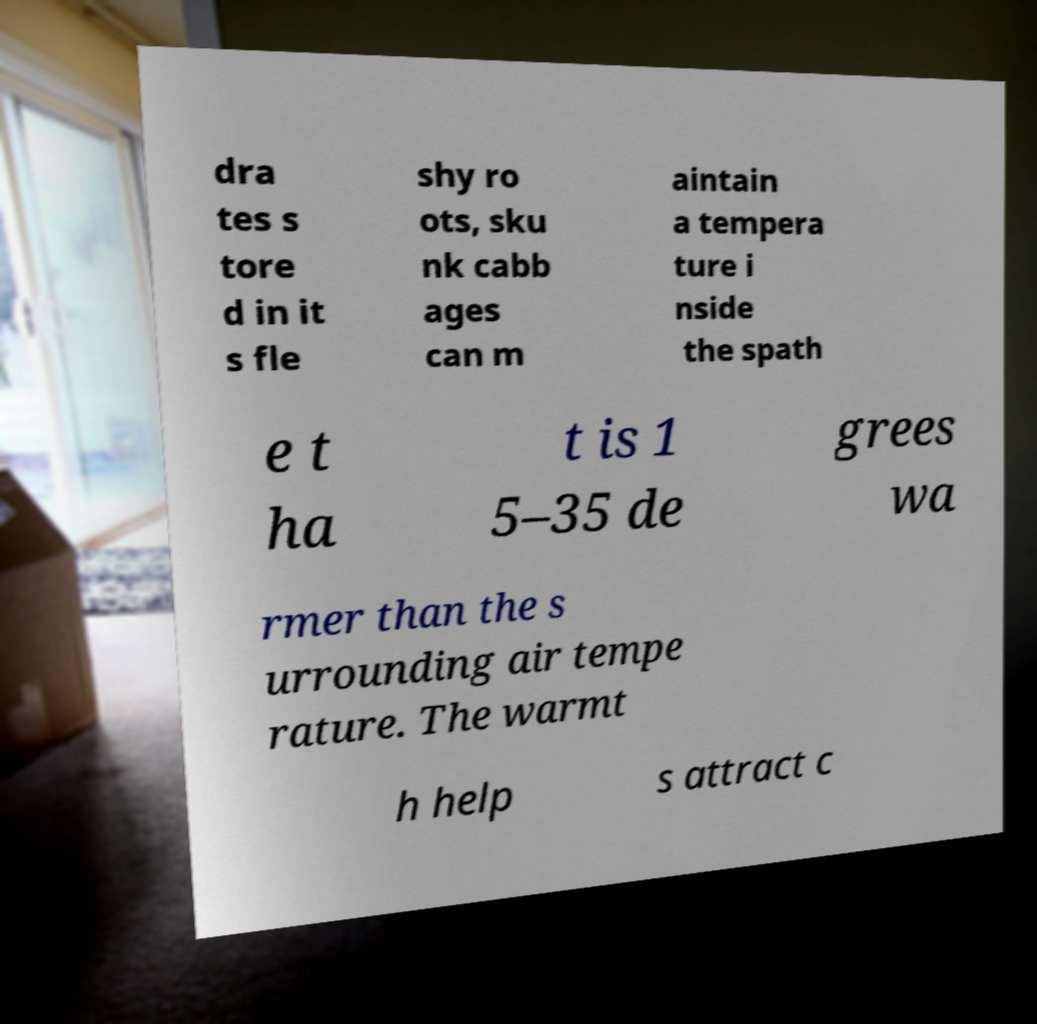Can you accurately transcribe the text from the provided image for me? dra tes s tore d in it s fle shy ro ots, sku nk cabb ages can m aintain a tempera ture i nside the spath e t ha t is 1 5–35 de grees wa rmer than the s urrounding air tempe rature. The warmt h help s attract c 